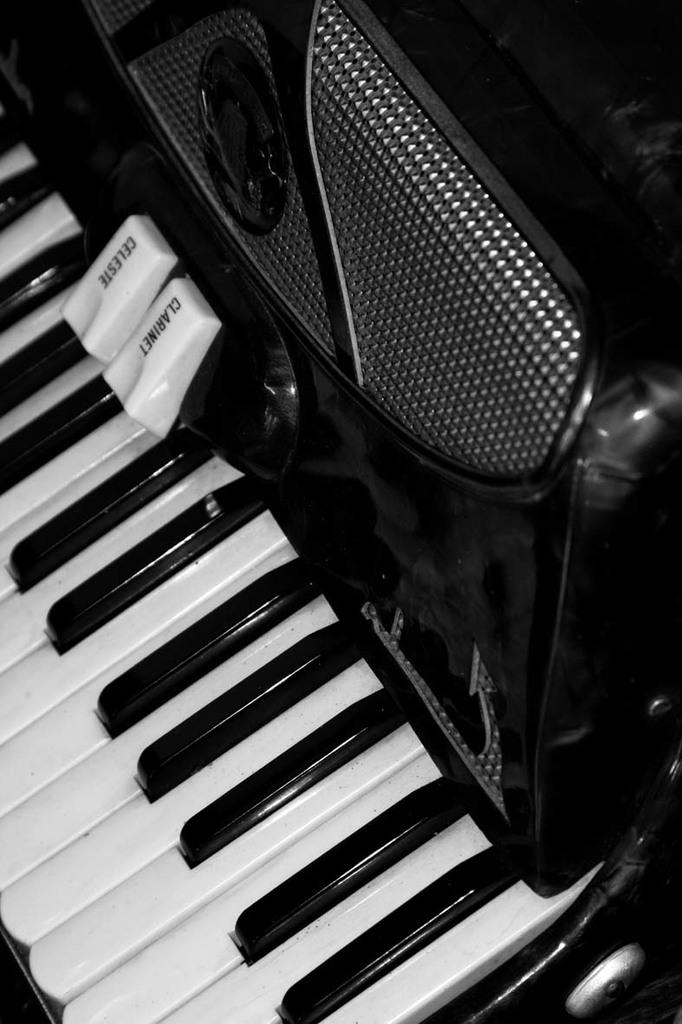What musical instrument is present in the image? There is a piano in the image. What day of the week is depicted on the calendar next to the piano? There is no calendar present in the image, so it is not possible to determine the day of the week. 